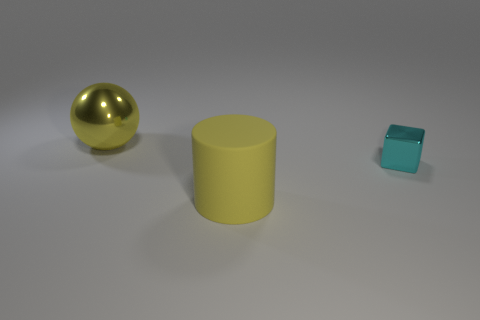What can you infer about the lighting and atmosphere of the setting? The setting appears to be evenly lit with soft, diffused lighting, suggesting an indoor scene, possibly a studio setup. There's no harsh shadows or highlights, which implies that the light source is large or there are multiple light sources. The neutral background enhances the focus on the objects. 